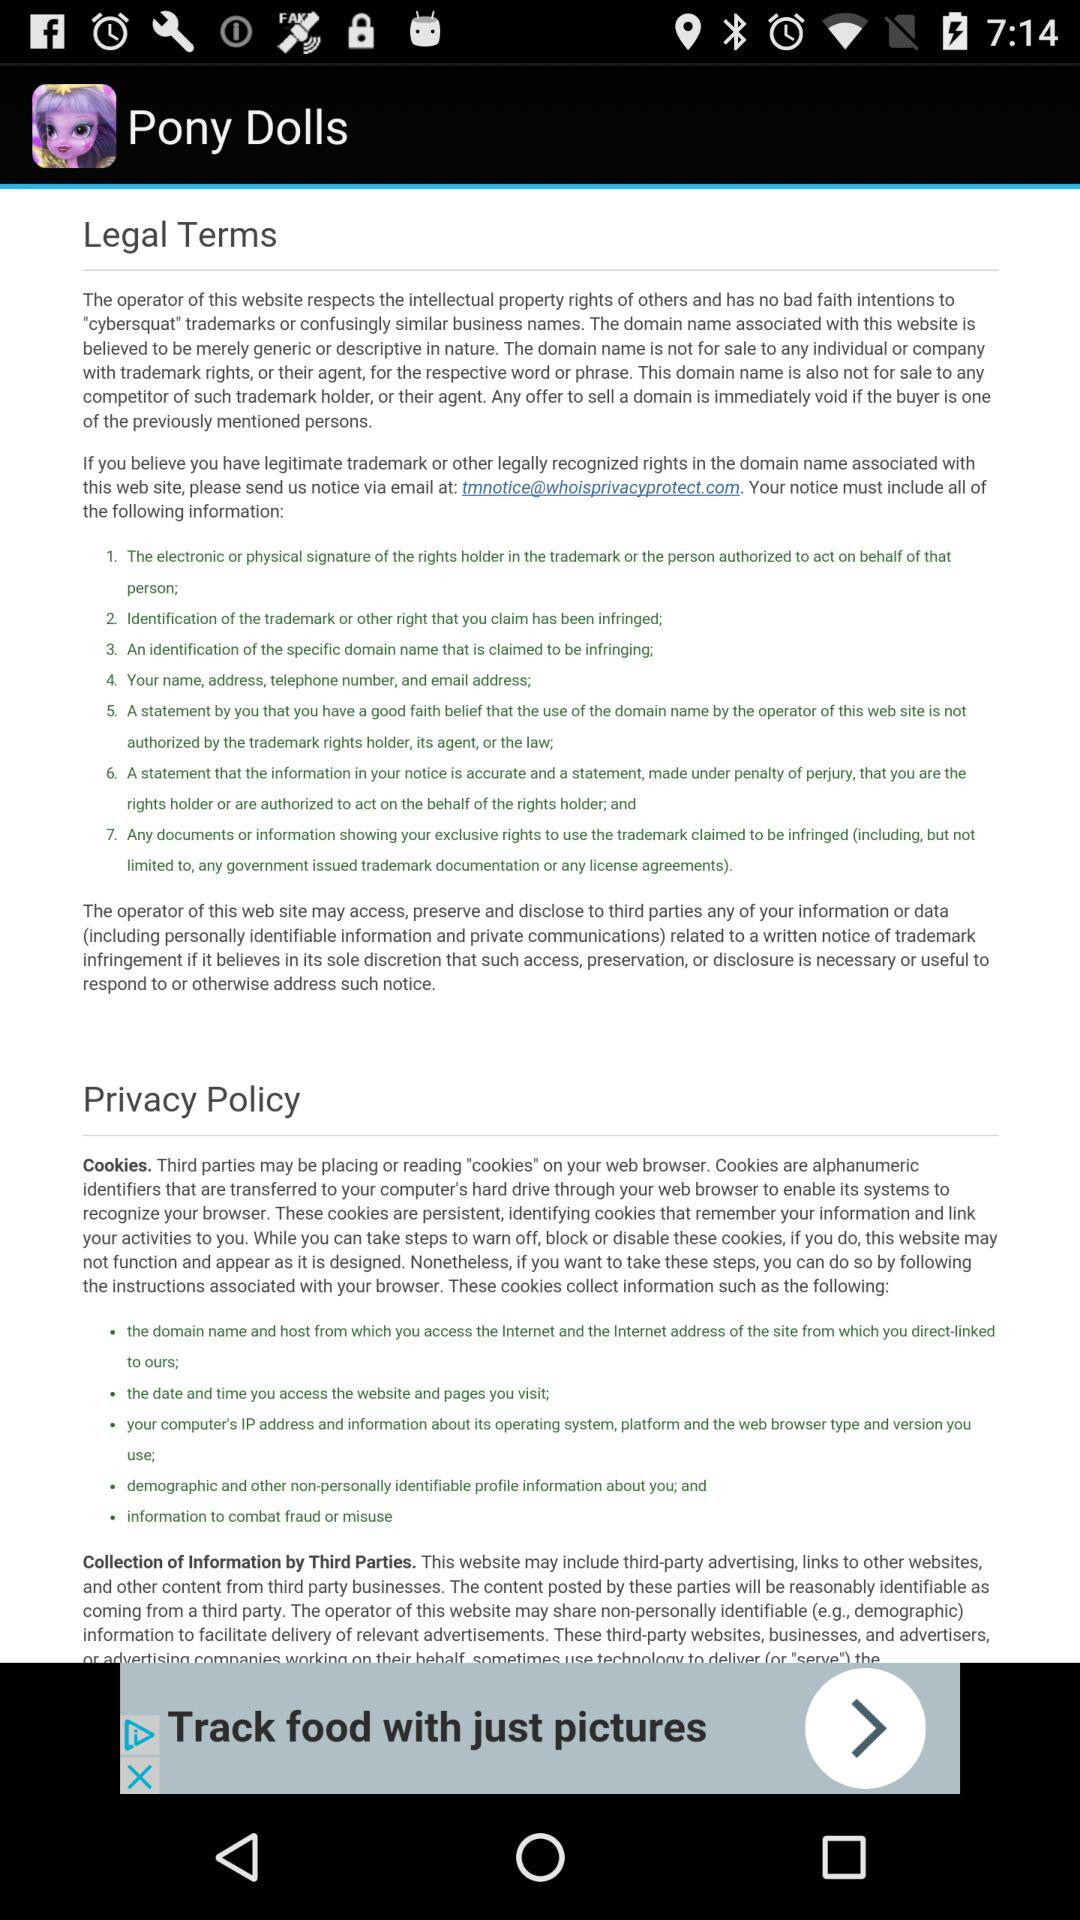Which version of "Pony Dolls" is this?
When the provided information is insufficient, respond with <no answer>. <no answer> 